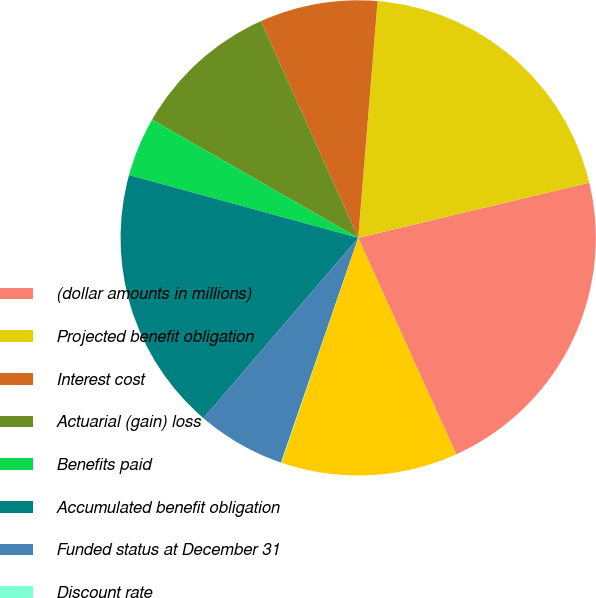Convert chart to OTSL. <chart><loc_0><loc_0><loc_500><loc_500><pie_chart><fcel>(dollar amounts in millions)<fcel>Projected benefit obligation<fcel>Interest cost<fcel>Actuarial (gain) loss<fcel>Benefits paid<fcel>Accumulated benefit obligation<fcel>Funded status at December 31<fcel>Discount rate<fcel>Net actuarial loss<nl><fcel>21.96%<fcel>19.97%<fcel>8.01%<fcel>10.0%<fcel>4.03%<fcel>17.97%<fcel>6.02%<fcel>0.04%<fcel>12.0%<nl></chart> 